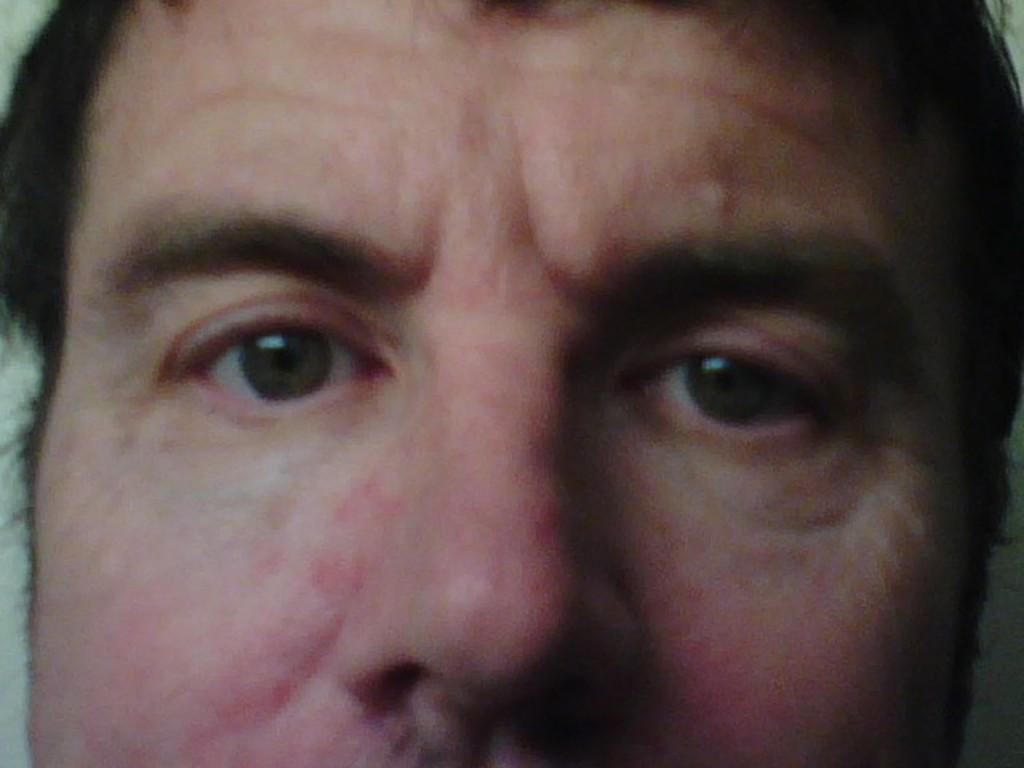Describe this image in one or two sentences. In this picture we can see a person's face. 